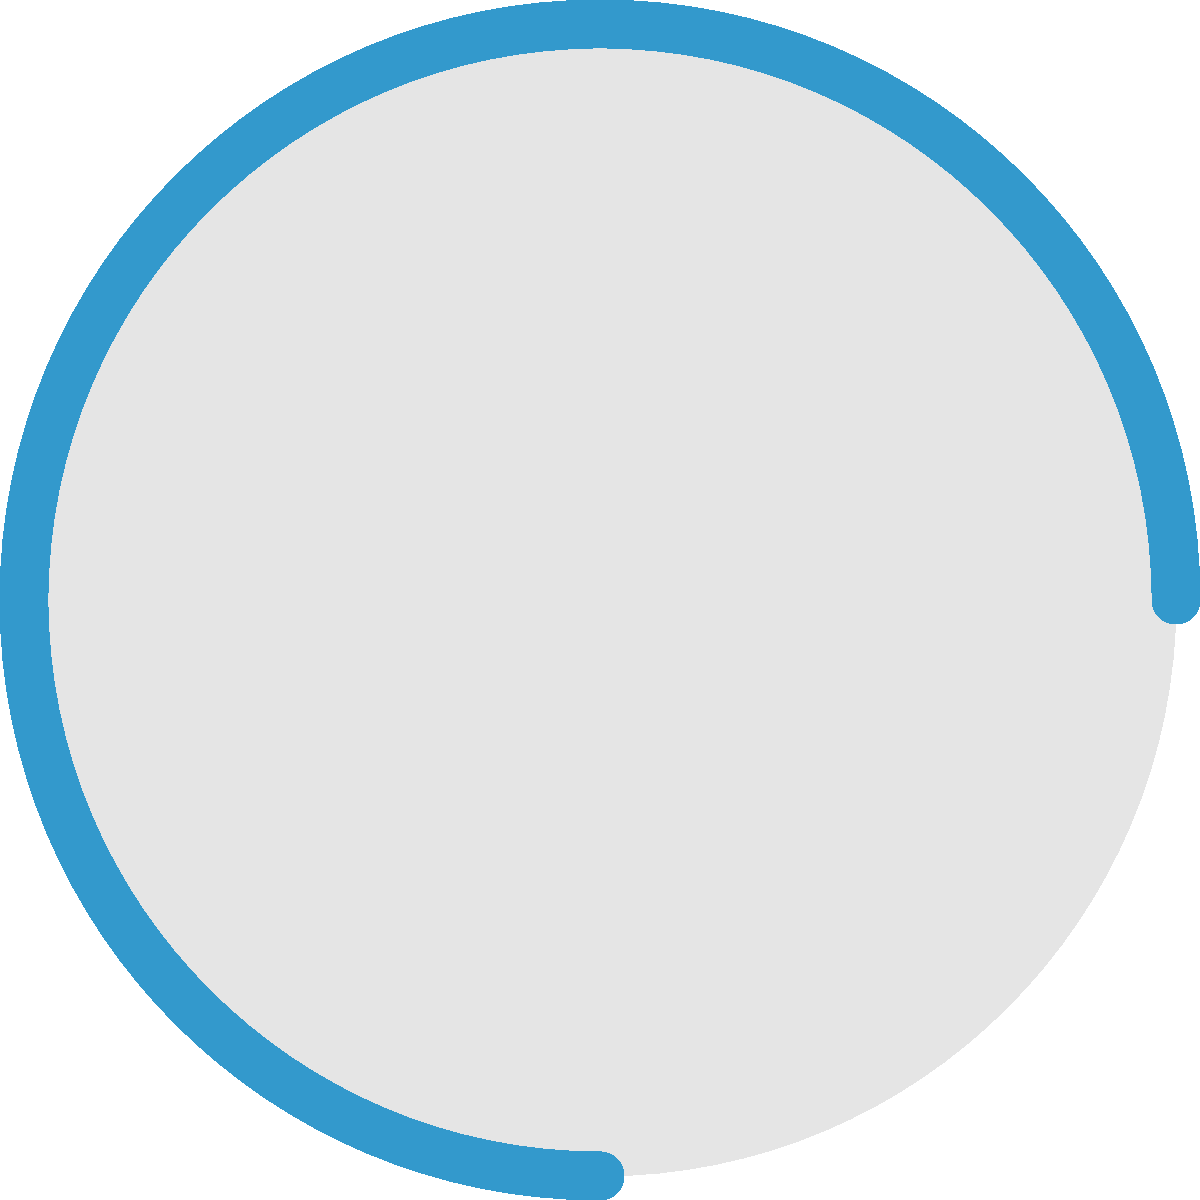Consider the circular loading animation shown above, commonly seen in retro video games. If each frame of the animation represents an element of a cyclic group, and the animation completes one full rotation in 8 frames, what is the order of the group represented by this loading animation? Additionally, how many elements would generate this group? Let's approach this step-by-step:

1) First, we need to understand what each frame represents in terms of group theory:
   - Each frame is an element of the cyclic group.
   - The identity element is the starting position (0° rotation).
   - Each subsequent frame is a rotation by a certain angle.

2) We're told that the animation completes one full rotation in 8 frames:
   - This means that the group has 8 distinct elements.
   - Each element represents a rotation of $360°/8 = 45°$.

3) In group theory, the order of a group is the number of elements in the group:
   - Therefore, the order of this group is 8.

4) To determine how many elements would generate this group, we need to find the generators:
   - In a cyclic group of order $n$, the generators are the elements that are coprime to $n$.
   - The numbers coprime to 8 are 1, 3, 5, and 7.

5) Let's verify:
   - Rotating by $45°$ (1/8 of a full rotation) 8 times gives a full rotation: generator.
   - Rotating by $135°$ (3/8 of a full rotation) 8 times gives 3 full rotations: generator.
   - Rotating by $225°$ (5/8 of a full rotation) 8 times gives 5 full rotations: generator.
   - Rotating by $315°$ (7/8 of a full rotation) 8 times gives 7 full rotations: generator.

Therefore, there are 4 elements that would generate this group.
Answer: Order: 8, Generators: 4 